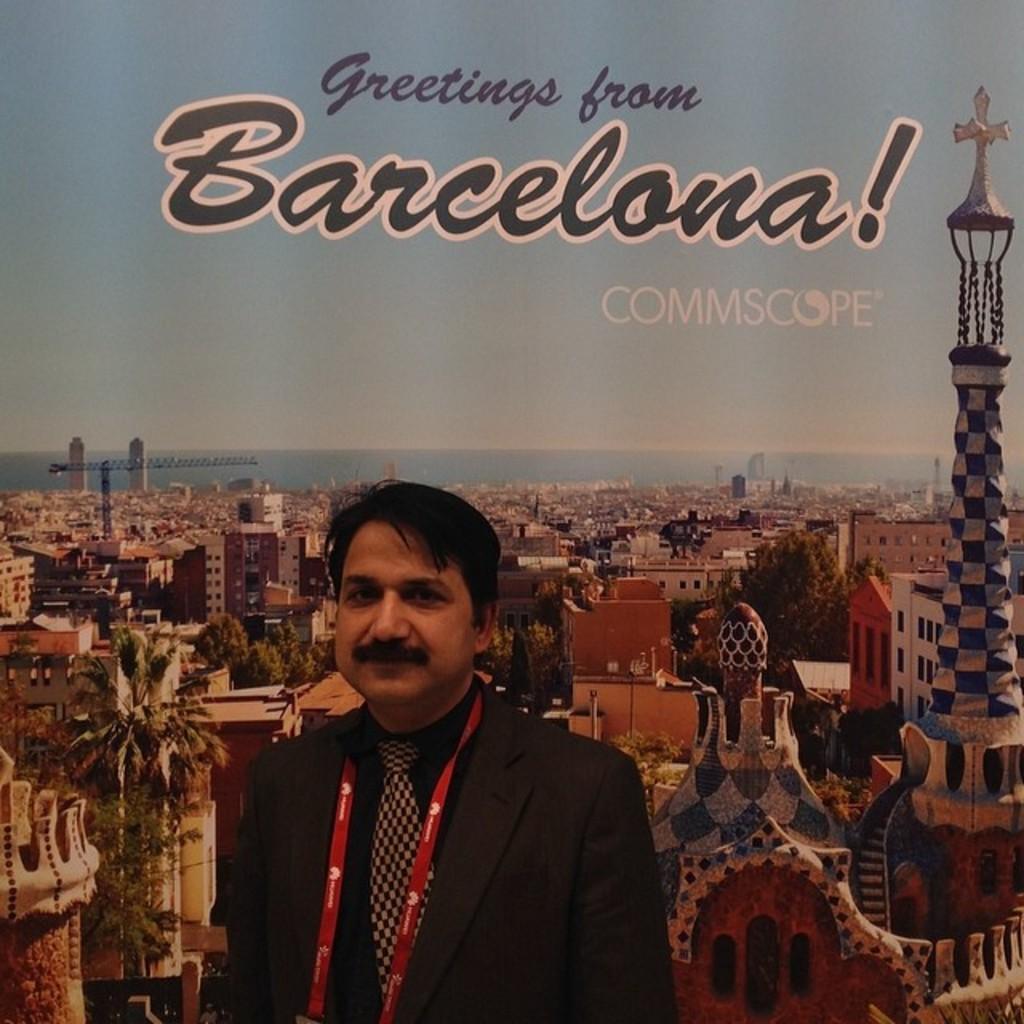Please provide a concise description of this image. In the background we can see the sky. We can see there is something written. In this picture we can see the skyscrapers, buildings, trees. On the right side of the picture we can see the holy church. At the top we can see the holy cross symbol. In this picture we can see a man wearing a tag, shirt, blazer and a tie. 